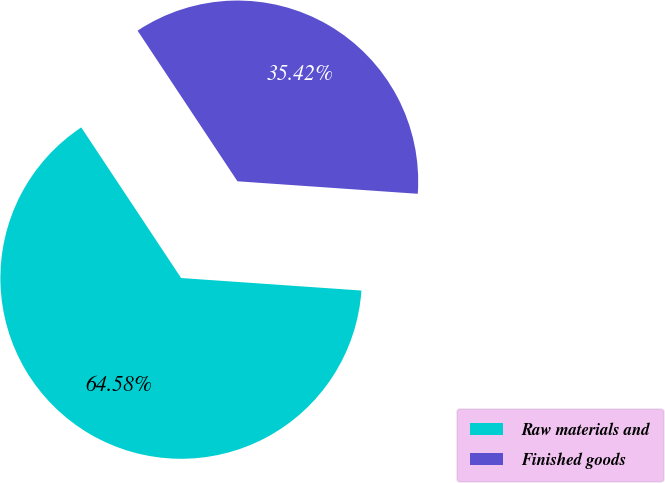Convert chart. <chart><loc_0><loc_0><loc_500><loc_500><pie_chart><fcel>Raw materials and<fcel>Finished goods<nl><fcel>64.58%<fcel>35.42%<nl></chart> 